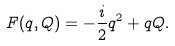<formula> <loc_0><loc_0><loc_500><loc_500>F ( q , Q ) = - { \frac { i } { 2 } } q ^ { 2 } + q Q .</formula> 